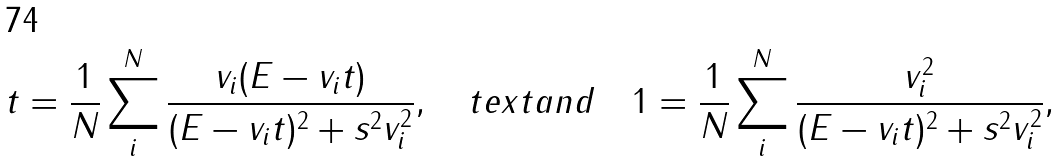<formula> <loc_0><loc_0><loc_500><loc_500>t = \frac { 1 } { N } \sum _ { i } ^ { N } \frac { v _ { i } ( E - v _ { i } t ) } { ( E - v _ { i } t ) ^ { 2 } + s ^ { 2 } v _ { i } ^ { 2 } } , \quad t e x t { a n d } \quad 1 = \frac { 1 } { N } \sum _ { i } ^ { N } \frac { v _ { i } ^ { 2 } } { ( E - v _ { i } t ) ^ { 2 } + s ^ { 2 } v _ { i } ^ { 2 } } ,</formula> 